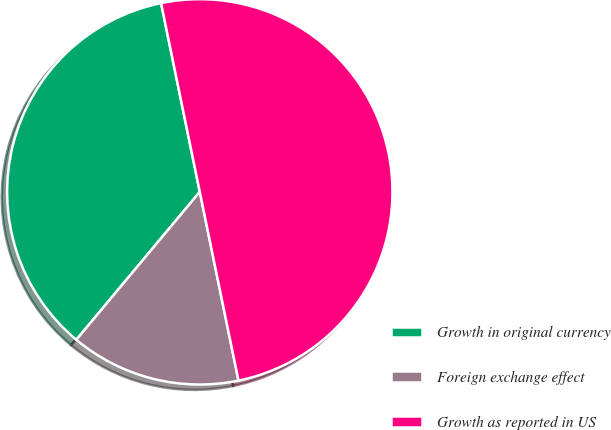Convert chart to OTSL. <chart><loc_0><loc_0><loc_500><loc_500><pie_chart><fcel>Growth in original currency<fcel>Foreign exchange effect<fcel>Growth as reported in US<nl><fcel>35.71%<fcel>14.29%<fcel>50.0%<nl></chart> 